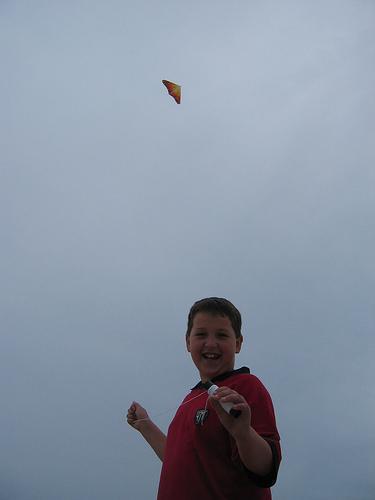How many people are in the photo?
Give a very brief answer. 1. How many kites are visible?
Give a very brief answer. 1. 